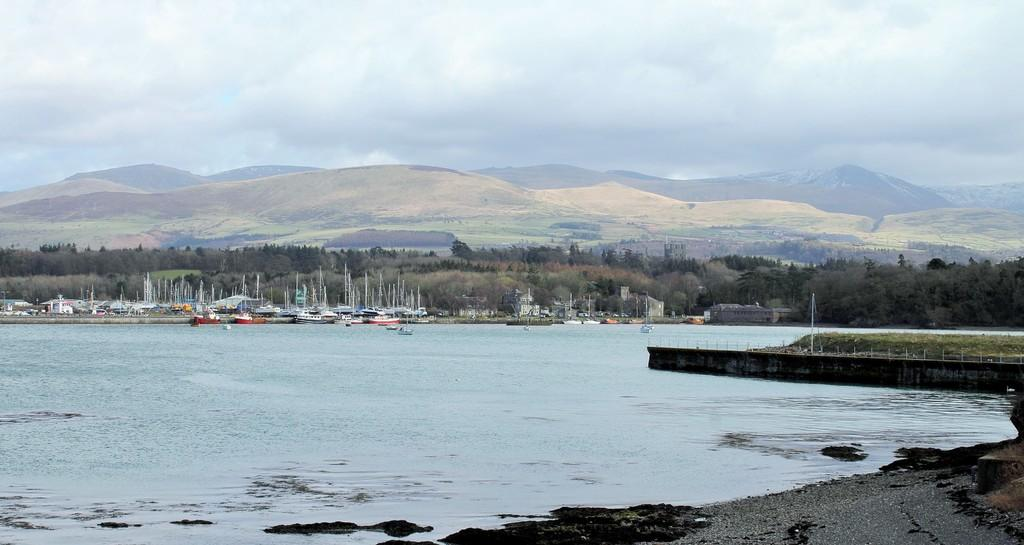What type of vegetation can be seen in the image? There are trees in the image. What is floating on the water in the image? There are boats floating on the water in the image. What geographical feature is located in the middle of the image? There are hills in the middle of the image. What is visible at the top of the image? The sky is visible at the top of the image. Can you tell me how many bananas are hanging from the trees in the image? There are no bananas visible in the image; only trees are present. What time is displayed on the clock in the image? There is no clock present in the image. 